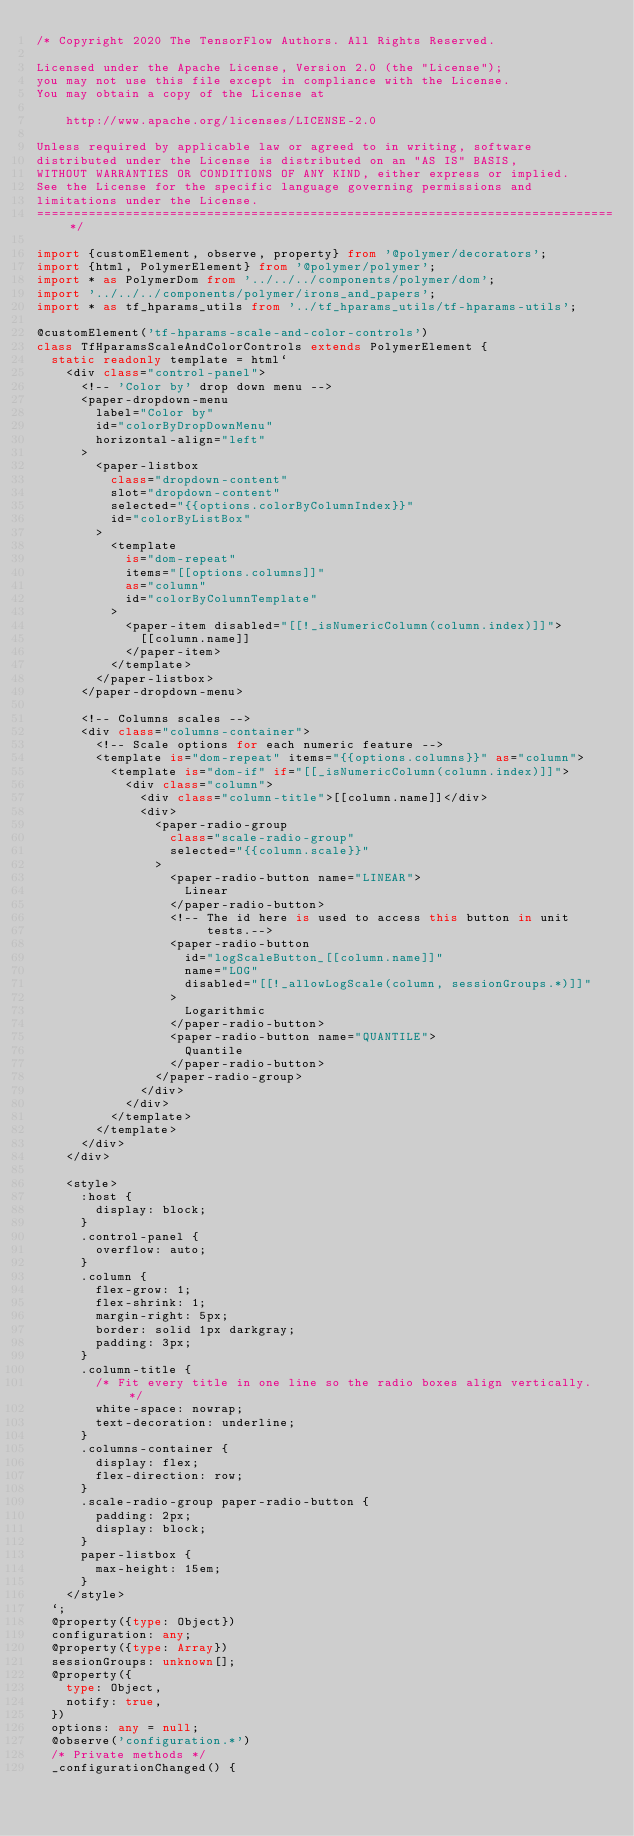<code> <loc_0><loc_0><loc_500><loc_500><_TypeScript_>/* Copyright 2020 The TensorFlow Authors. All Rights Reserved.

Licensed under the Apache License, Version 2.0 (the "License");
you may not use this file except in compliance with the License.
You may obtain a copy of the License at

    http://www.apache.org/licenses/LICENSE-2.0

Unless required by applicable law or agreed to in writing, software
distributed under the License is distributed on an "AS IS" BASIS,
WITHOUT WARRANTIES OR CONDITIONS OF ANY KIND, either express or implied.
See the License for the specific language governing permissions and
limitations under the License.
==============================================================================*/

import {customElement, observe, property} from '@polymer/decorators';
import {html, PolymerElement} from '@polymer/polymer';
import * as PolymerDom from '../../../components/polymer/dom';
import '../../../components/polymer/irons_and_papers';
import * as tf_hparams_utils from '../tf_hparams_utils/tf-hparams-utils';

@customElement('tf-hparams-scale-and-color-controls')
class TfHparamsScaleAndColorControls extends PolymerElement {
  static readonly template = html`
    <div class="control-panel">
      <!-- 'Color by' drop down menu -->
      <paper-dropdown-menu
        label="Color by"
        id="colorByDropDownMenu"
        horizontal-align="left"
      >
        <paper-listbox
          class="dropdown-content"
          slot="dropdown-content"
          selected="{{options.colorByColumnIndex}}"
          id="colorByListBox"
        >
          <template
            is="dom-repeat"
            items="[[options.columns]]"
            as="column"
            id="colorByColumnTemplate"
          >
            <paper-item disabled="[[!_isNumericColumn(column.index)]]">
              [[column.name]]
            </paper-item>
          </template>
        </paper-listbox>
      </paper-dropdown-menu>

      <!-- Columns scales -->
      <div class="columns-container">
        <!-- Scale options for each numeric feature -->
        <template is="dom-repeat" items="{{options.columns}}" as="column">
          <template is="dom-if" if="[[_isNumericColumn(column.index)]]">
            <div class="column">
              <div class="column-title">[[column.name]]</div>
              <div>
                <paper-radio-group
                  class="scale-radio-group"
                  selected="{{column.scale}}"
                >
                  <paper-radio-button name="LINEAR">
                    Linear
                  </paper-radio-button>
                  <!-- The id here is used to access this button in unit
                       tests.-->
                  <paper-radio-button
                    id="logScaleButton_[[column.name]]"
                    name="LOG"
                    disabled="[[!_allowLogScale(column, sessionGroups.*)]]"
                  >
                    Logarithmic
                  </paper-radio-button>
                  <paper-radio-button name="QUANTILE">
                    Quantile
                  </paper-radio-button>
                </paper-radio-group>
              </div>
            </div>
          </template>
        </template>
      </div>
    </div>

    <style>
      :host {
        display: block;
      }
      .control-panel {
        overflow: auto;
      }
      .column {
        flex-grow: 1;
        flex-shrink: 1;
        margin-right: 5px;
        border: solid 1px darkgray;
        padding: 3px;
      }
      .column-title {
        /* Fit every title in one line so the radio boxes align vertically. */
        white-space: nowrap;
        text-decoration: underline;
      }
      .columns-container {
        display: flex;
        flex-direction: row;
      }
      .scale-radio-group paper-radio-button {
        padding: 2px;
        display: block;
      }
      paper-listbox {
        max-height: 15em;
      }
    </style>
  `;
  @property({type: Object})
  configuration: any;
  @property({type: Array})
  sessionGroups: unknown[];
  @property({
    type: Object,
    notify: true,
  })
  options: any = null;
  @observe('configuration.*')
  /* Private methods */
  _configurationChanged() {</code> 